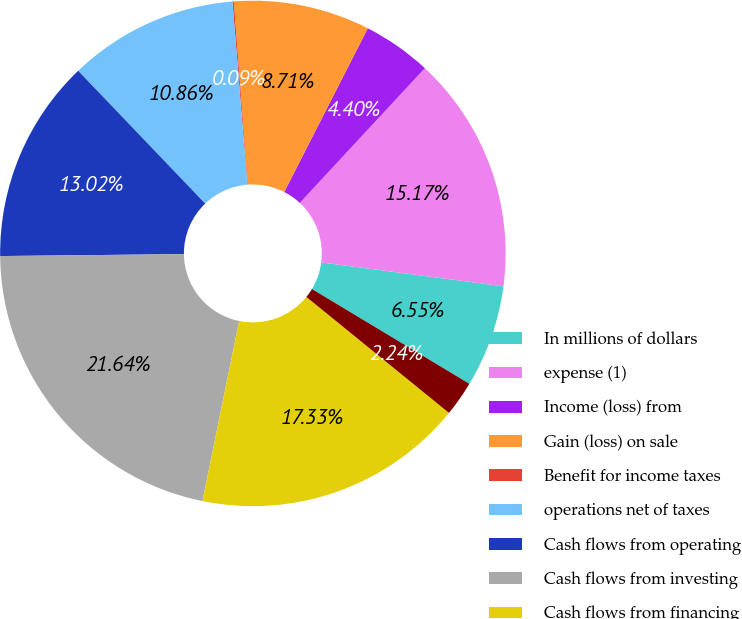Convert chart. <chart><loc_0><loc_0><loc_500><loc_500><pie_chart><fcel>In millions of dollars<fcel>expense (1)<fcel>Income (loss) from<fcel>Gain (loss) on sale<fcel>Benefit for income taxes<fcel>operations net of taxes<fcel>Cash flows from operating<fcel>Cash flows from investing<fcel>Cash flows from financing<fcel>discontinued operations<nl><fcel>6.55%<fcel>15.17%<fcel>4.4%<fcel>8.71%<fcel>0.09%<fcel>10.86%<fcel>13.02%<fcel>21.64%<fcel>17.33%<fcel>2.24%<nl></chart> 